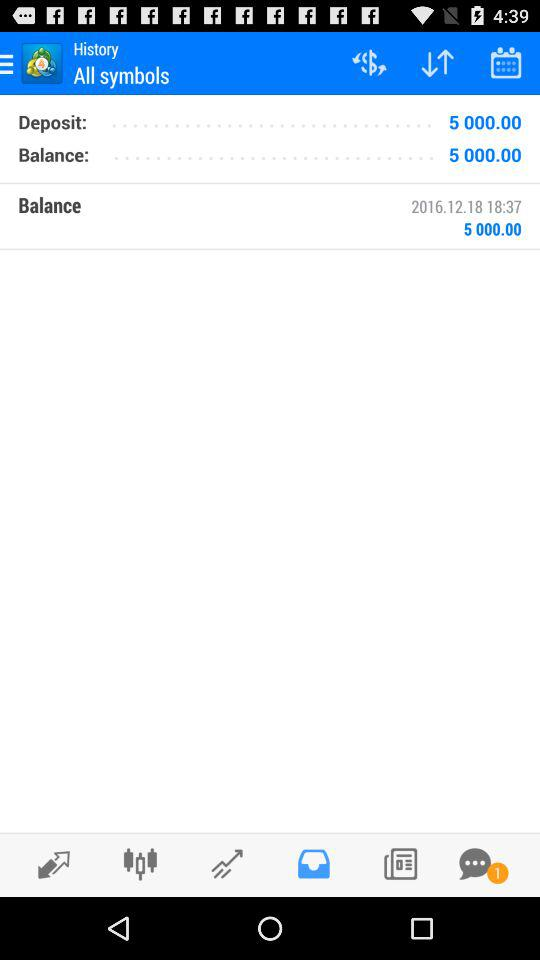What date is shown in the "Balance" section? The shown date is December 18, 2016. 